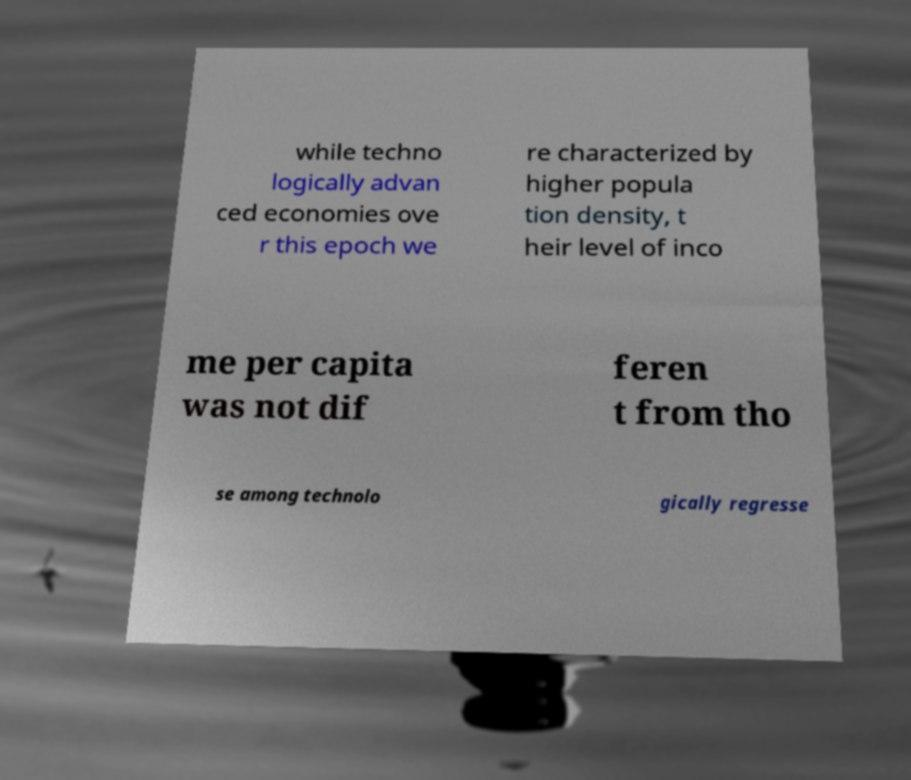Could you extract and type out the text from this image? while techno logically advan ced economies ove r this epoch we re characterized by higher popula tion density, t heir level of inco me per capita was not dif feren t from tho se among technolo gically regresse 